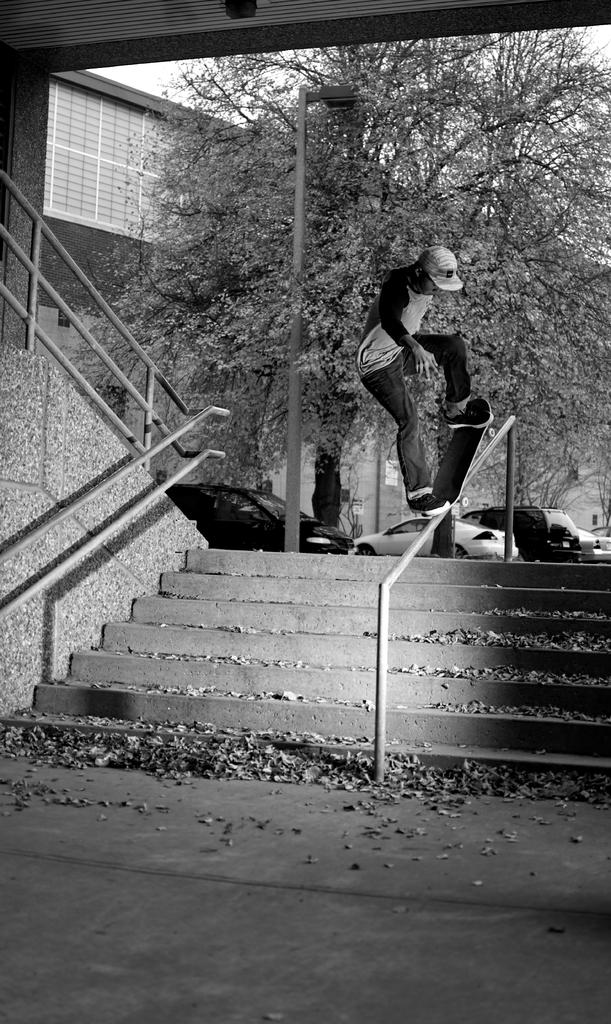What is the color scheme of the image? The image is black and white. What is the person in the image doing? The person is riding a skateboard in the image. What can be seen in the background of the image? There are vehicles, a pole, trees, a wall, and the sky visible in the background of the image. What type of smell can be detected in the image? There is no information about smells in the image, as it is a visual medium. --- Facts: 1. There is a person holding a book in the image. 2. The person is sitting on a chair. 3. There is a table in front of the person. 4. The book has a red cover. 5. The chair has a cushion. Absurd Topics: ocean, dance, bird Conversation: What is the person in the image holding? The person is holding a book in the image. What is the person's position in the image? The person is sitting on a chair in the image. What is in front of the person? There is a table in front of the person. What is the color of the book's cover? The book has a red cover. What is the chair's condition? The chair has a cushion. Reasoning: Let's think step by step in order to produce the conversation. We start by identifying the main subject in the image, which is the person holding a book. Then, we expand the conversation to include the person's position and the presence of a table. Next, we describe the book's cover color and the chair's condition. Each question is designed to elicit a specific detail about the image that is known from the provided facts. Absurd Question/Answer: Can you see any birds flying over the ocean in the image? There is no ocean or birds present in the image; it features a person sitting on a chair holding a book. 